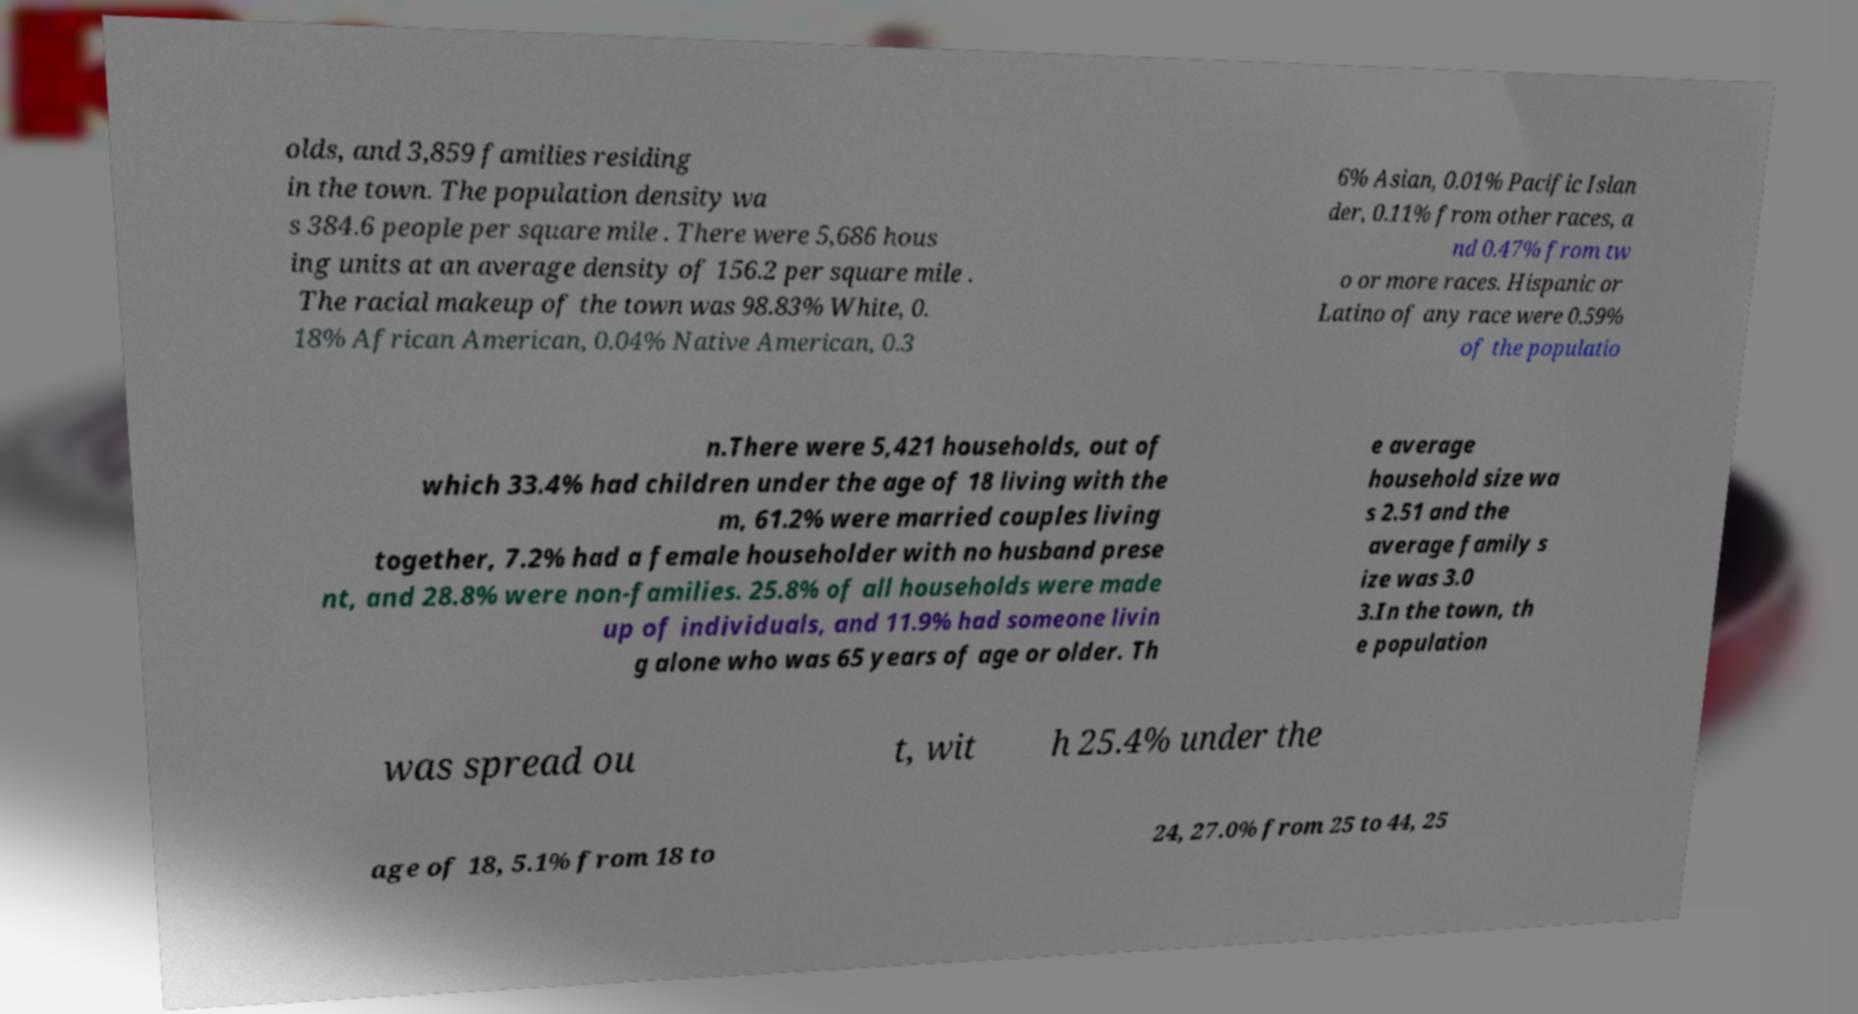Please read and relay the text visible in this image. What does it say? olds, and 3,859 families residing in the town. The population density wa s 384.6 people per square mile . There were 5,686 hous ing units at an average density of 156.2 per square mile . The racial makeup of the town was 98.83% White, 0. 18% African American, 0.04% Native American, 0.3 6% Asian, 0.01% Pacific Islan der, 0.11% from other races, a nd 0.47% from tw o or more races. Hispanic or Latino of any race were 0.59% of the populatio n.There were 5,421 households, out of which 33.4% had children under the age of 18 living with the m, 61.2% were married couples living together, 7.2% had a female householder with no husband prese nt, and 28.8% were non-families. 25.8% of all households were made up of individuals, and 11.9% had someone livin g alone who was 65 years of age or older. Th e average household size wa s 2.51 and the average family s ize was 3.0 3.In the town, th e population was spread ou t, wit h 25.4% under the age of 18, 5.1% from 18 to 24, 27.0% from 25 to 44, 25 